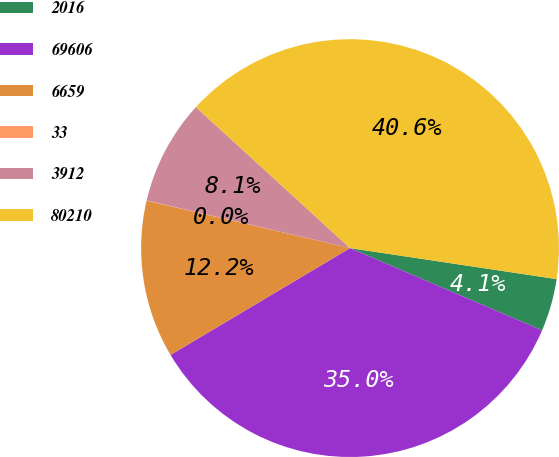Convert chart. <chart><loc_0><loc_0><loc_500><loc_500><pie_chart><fcel>2016<fcel>69606<fcel>6659<fcel>33<fcel>3912<fcel>80210<nl><fcel>4.07%<fcel>35.02%<fcel>12.19%<fcel>0.02%<fcel>8.13%<fcel>40.58%<nl></chart> 